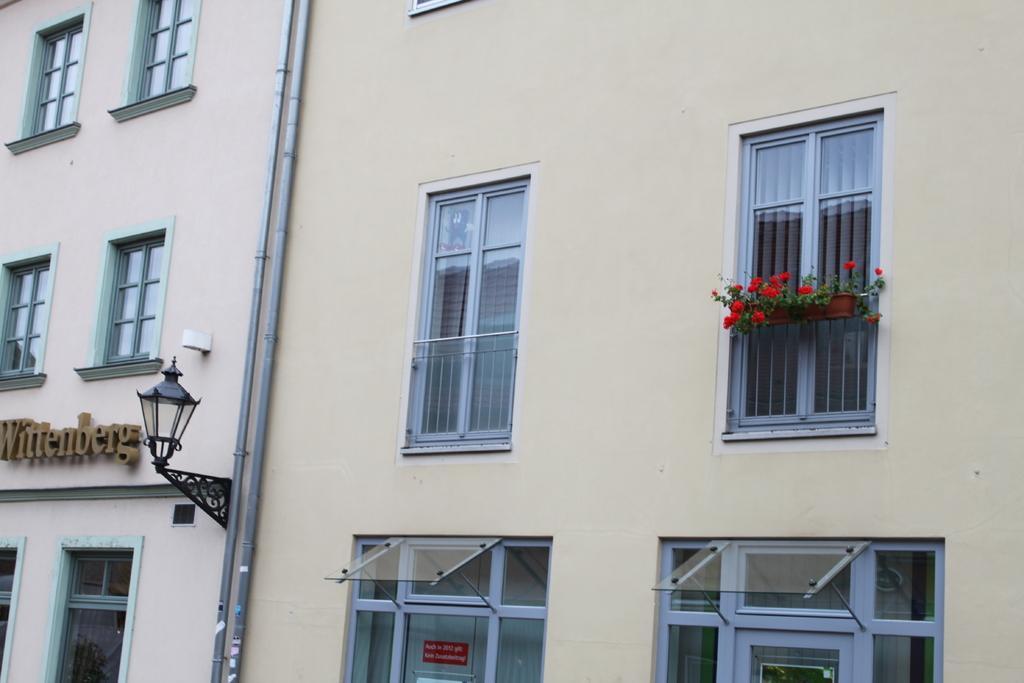How would you summarize this image in a sentence or two? In this picture we can see the sidewall of a building with many windows, flower pots, a pipeline and a lamp post. 